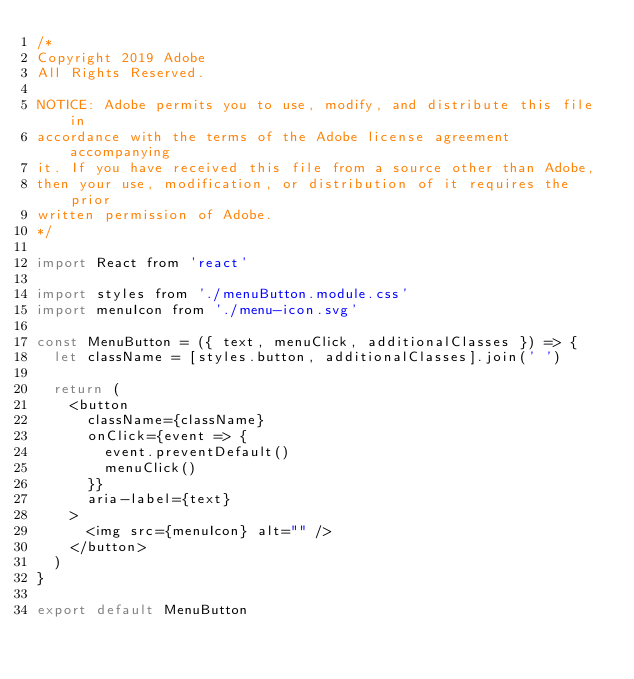Convert code to text. <code><loc_0><loc_0><loc_500><loc_500><_JavaScript_>/*
Copyright 2019 Adobe
All Rights Reserved.

NOTICE: Adobe permits you to use, modify, and distribute this file in
accordance with the terms of the Adobe license agreement accompanying
it. If you have received this file from a source other than Adobe,
then your use, modification, or distribution of it requires the prior
written permission of Adobe. 
*/

import React from 'react'

import styles from './menuButton.module.css'
import menuIcon from './menu-icon.svg'

const MenuButton = ({ text, menuClick, additionalClasses }) => {
  let className = [styles.button, additionalClasses].join(' ')

  return (
    <button
      className={className}
      onClick={event => {
        event.preventDefault()
        menuClick()
      }}
      aria-label={text}
    >
      <img src={menuIcon} alt="" />
    </button>
  )
}

export default MenuButton
</code> 